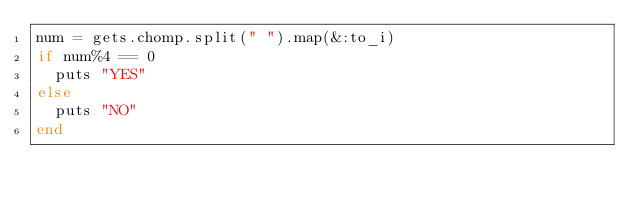Convert code to text. <code><loc_0><loc_0><loc_500><loc_500><_Ruby_>num = gets.chomp.split(" ").map(&:to_i)
if num%4 == 0
  puts "YES"
else
  puts "NO"
end
</code> 